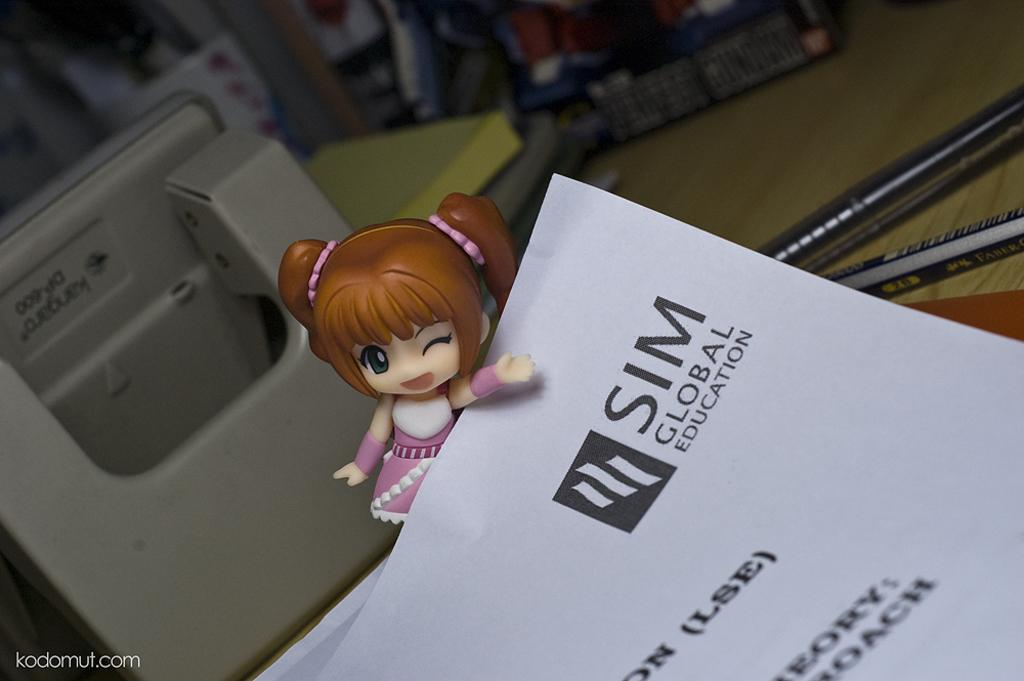What type of object can be seen in the image? There is a toy in the image. What else is present on the wooden surface in the image? Papers and pens are also present on the wooden surface in the image. Can you describe the objects on the wooden surface? The objects on the wooden surface include a toy, papers, and pens. How would you describe the background of the image? The background of the image is blurred. How many eyes can be seen on the toy in the image? There is no information about the toy's eyes in the provided facts, and therefore we cannot determine the number of eyes on the toy. What type of territory is depicted in the image? There is no territory depicted in the image; it features a toy, papers, pens, and a wooden surface. 